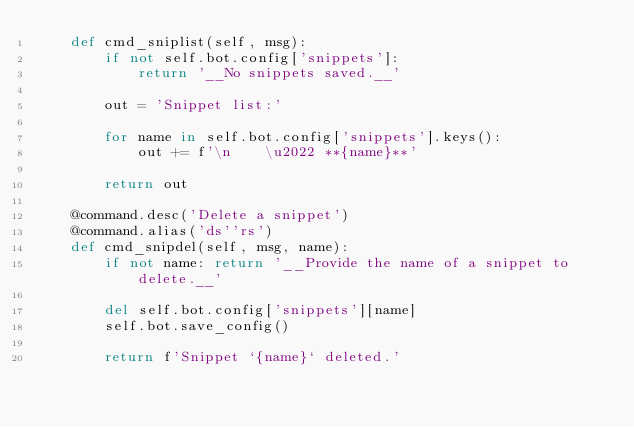<code> <loc_0><loc_0><loc_500><loc_500><_Python_>    def cmd_sniplist(self, msg):
        if not self.bot.config['snippets']:
            return '__No snippets saved.__'

        out = 'Snippet list:'

        for name in self.bot.config['snippets'].keys():
            out += f'\n    \u2022 **{name}**'

        return out

    @command.desc('Delete a snippet')
    @command.alias('ds''rs')
    def cmd_snipdel(self, msg, name):
        if not name: return '__Provide the name of a snippet to delete.__'

        del self.bot.config['snippets'][name]
        self.bot.save_config()

        return f'Snippet `{name}` deleted.'
</code> 